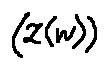<formula> <loc_0><loc_0><loc_500><loc_500>( z ( w ) )</formula> 